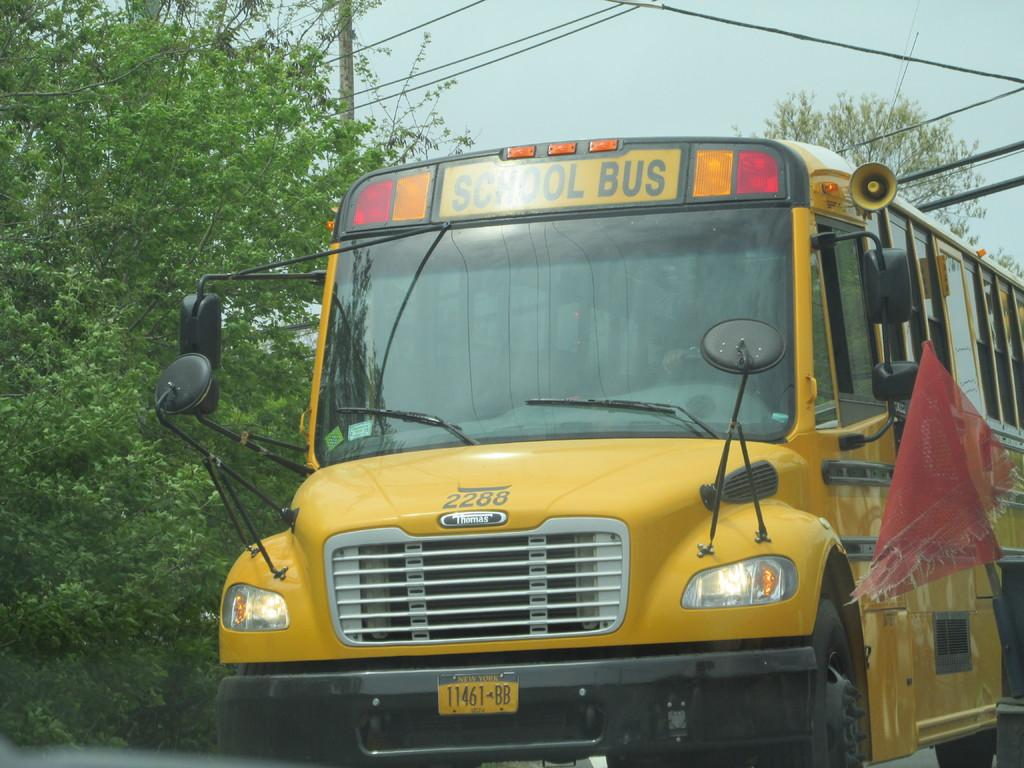What color is the bus in the image? The bus in the image is yellow-colored. Where is the bus located in the image? The bus is standing on the road. What is written on the bus? The words "School Bus" are written on the bus. What can be seen in the background of the image? There are trees visible in the background of the image. What is the belief of the bus in the image? The image does not convey any beliefs; it is a picture of a yellow-colored bus standing on the road with the words "School Bus" written on it. 